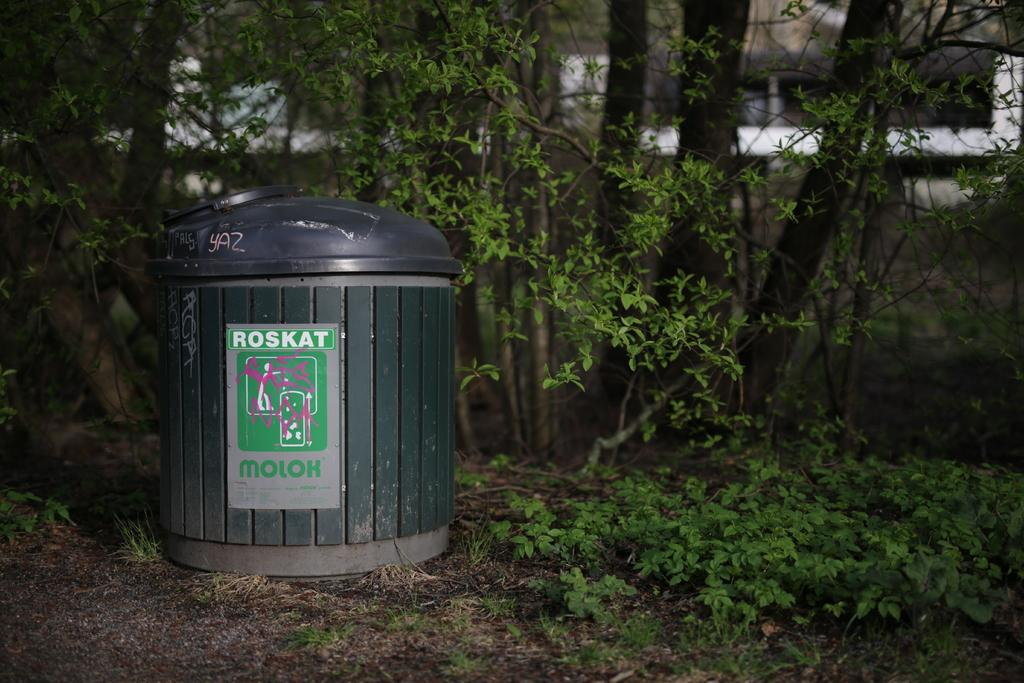<image>
Offer a succinct explanation of the picture presented. Roskat and Molok that are on the top and bottom of a can for trash it looks like. 